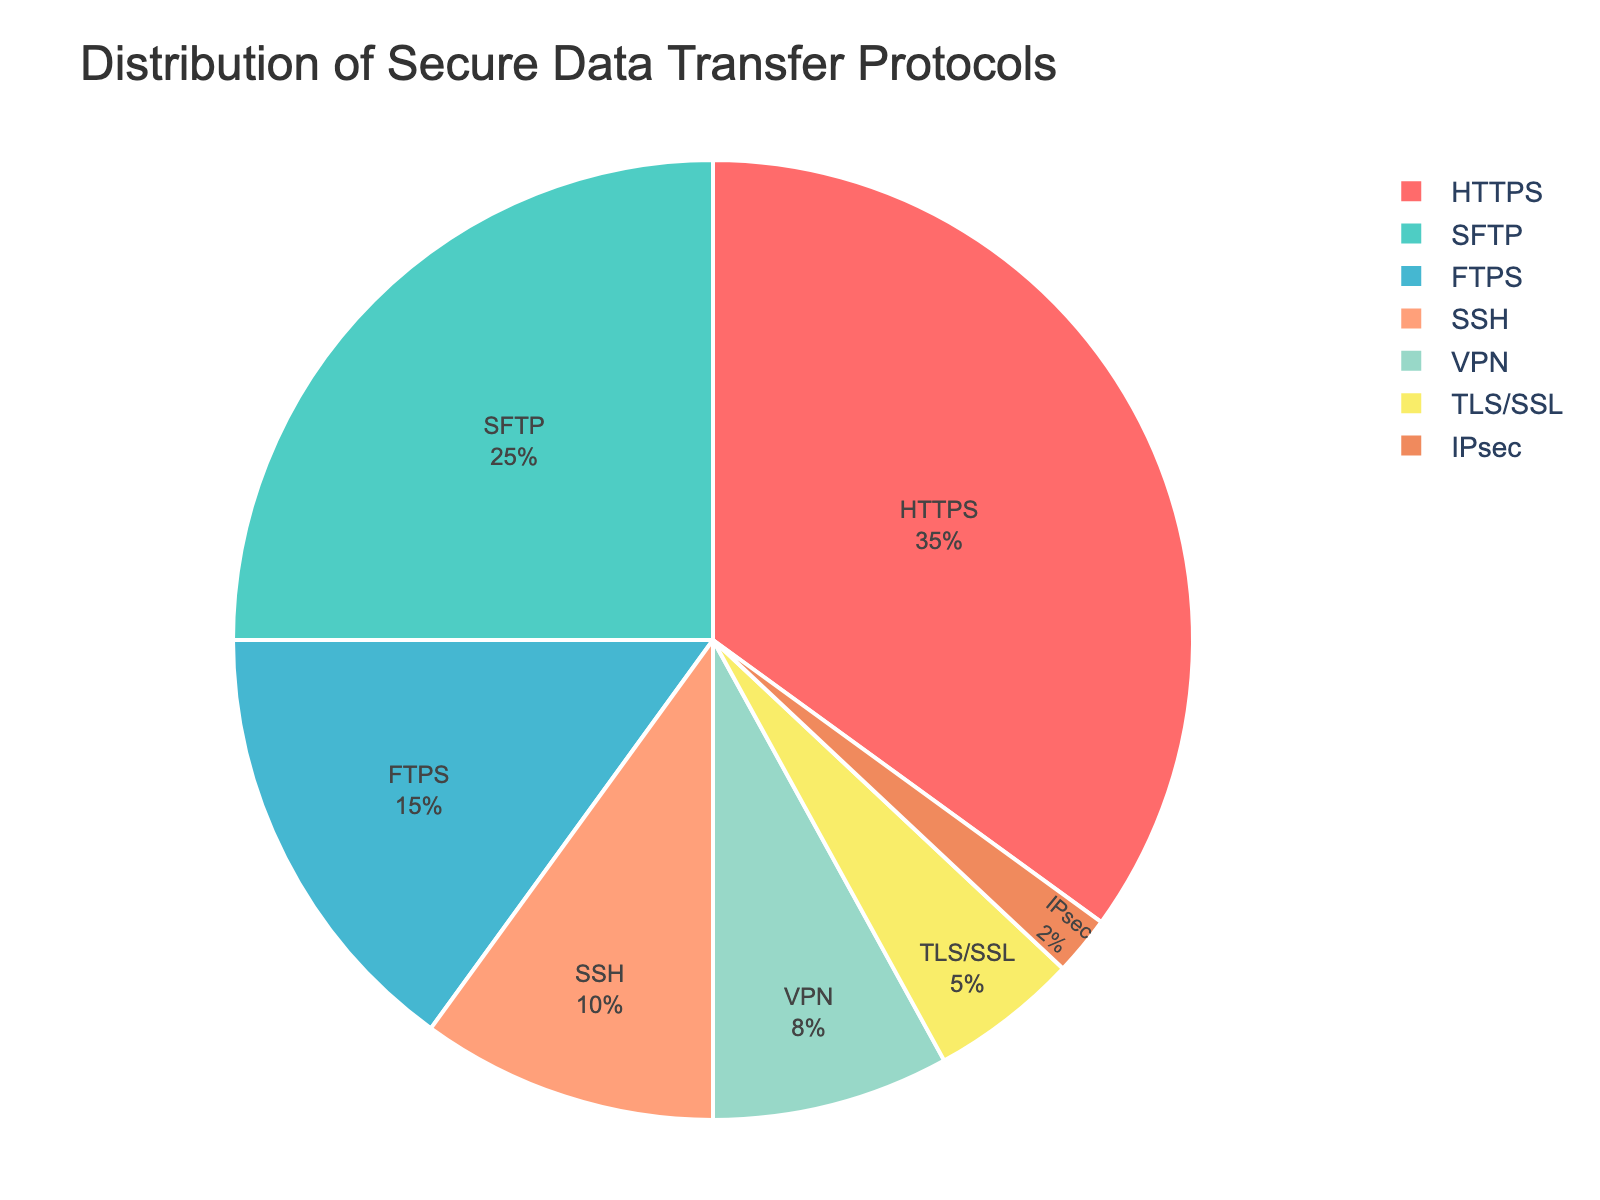What's the most commonly used secure data transfer protocol in enterprise environments? The figure shows that the largest segment of the pie chart represents HTTPS, which occupies 35% of the distribution, making it the most commonly used protocol.
Answer: HTTPS Which protocol has the smallest representation in this distribution? The smallest segment of the pie chart is for IPsec, which is only 2% of the distribution.
Answer: IPsec Combined, how much of the distribution do the SFTP and FTPS protocols account for? SFTP has 25% and FTPS has 15%. Adding these together: 25% + 15% = 40%.
Answer: 40% Is the percentage of VPN usage greater than that of SSH usage? VPN usage is 8%, whereas SSH usage is 10%. Since 8% is less than 10%, VPN usage is not greater than SSH usage.
Answer: No Which color is used to represent TLS/SSL in the pie chart? The TLS/SSL segment is represented by a yellowish color. This can be deduced by examining the segment with 5%, which corresponds to TLS/SSL.
Answer: Yellow What is the difference in percentage points between the HTTPS and FTPS protocols? HTTPS is 35% and FTPS is 15%. The difference is calculated as 35% - 15% = 20%.
Answer: 20% What percentage of the distribution is accounted for by non-HTTPS protocols? Subtract the percentage of HTTPS from the total: 100% - 35% = 65%.
Answer: 65% Of the protocols displayed, which one has nearly double the percentage representation of TLS/SSL? TLS/SSL is 5%, and the protocol with nearly double this is VPN at 8%, although it's not exactly double, it is reasonably close.
Answer: VPN Which two protocols together sum up to the same percentage as SFTP alone? SFTP is 25%. SSH (10%) and VPN (8%) together sum to 18%, while FTPS (15%) and VPN (8%) together sum to 23%. The exact match is not possible, but FTPS and VPN come the closest with 23%.
Answer: FTPS and VPN (close to 25%) 